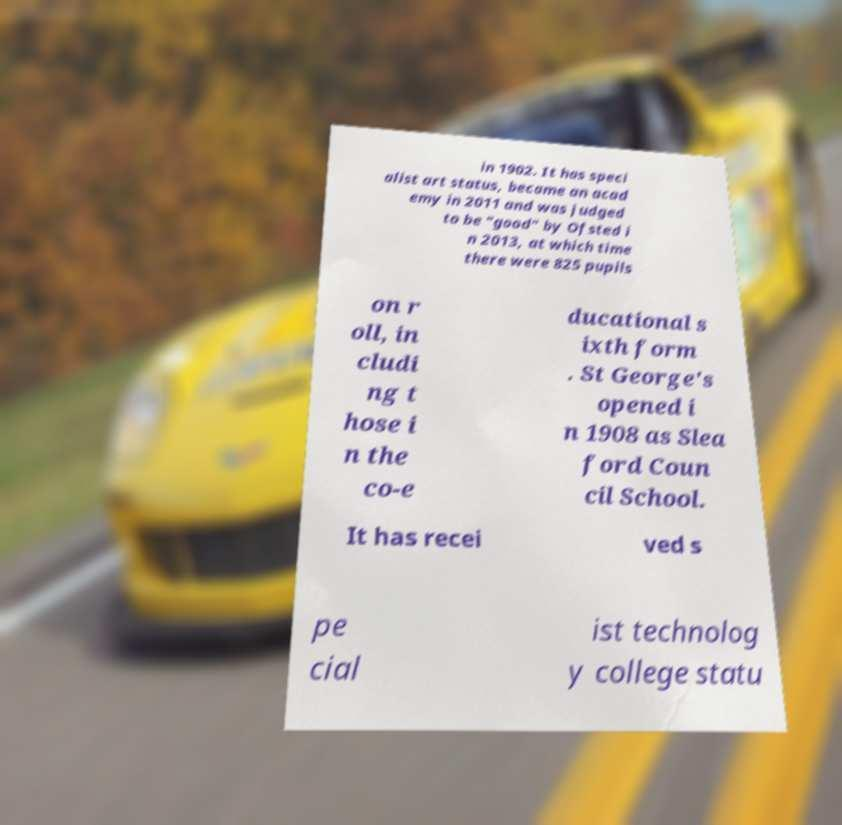Could you assist in decoding the text presented in this image and type it out clearly? in 1902. It has speci alist art status, became an acad emy in 2011 and was judged to be "good" by Ofsted i n 2013, at which time there were 825 pupils on r oll, in cludi ng t hose i n the co-e ducational s ixth form . St George's opened i n 1908 as Slea ford Coun cil School. It has recei ved s pe cial ist technolog y college statu 